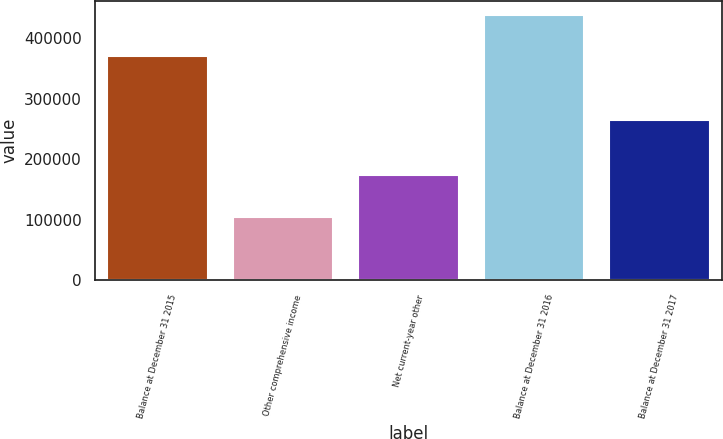Convert chart to OTSL. <chart><loc_0><loc_0><loc_500><loc_500><bar_chart><fcel>Balance at December 31 2015<fcel>Other comprehensive income<fcel>Net current-year other<fcel>Balance at December 31 2016<fcel>Balance at December 31 2017<nl><fcel>371124<fcel>103957<fcel>173626<fcel>438717<fcel>265091<nl></chart> 